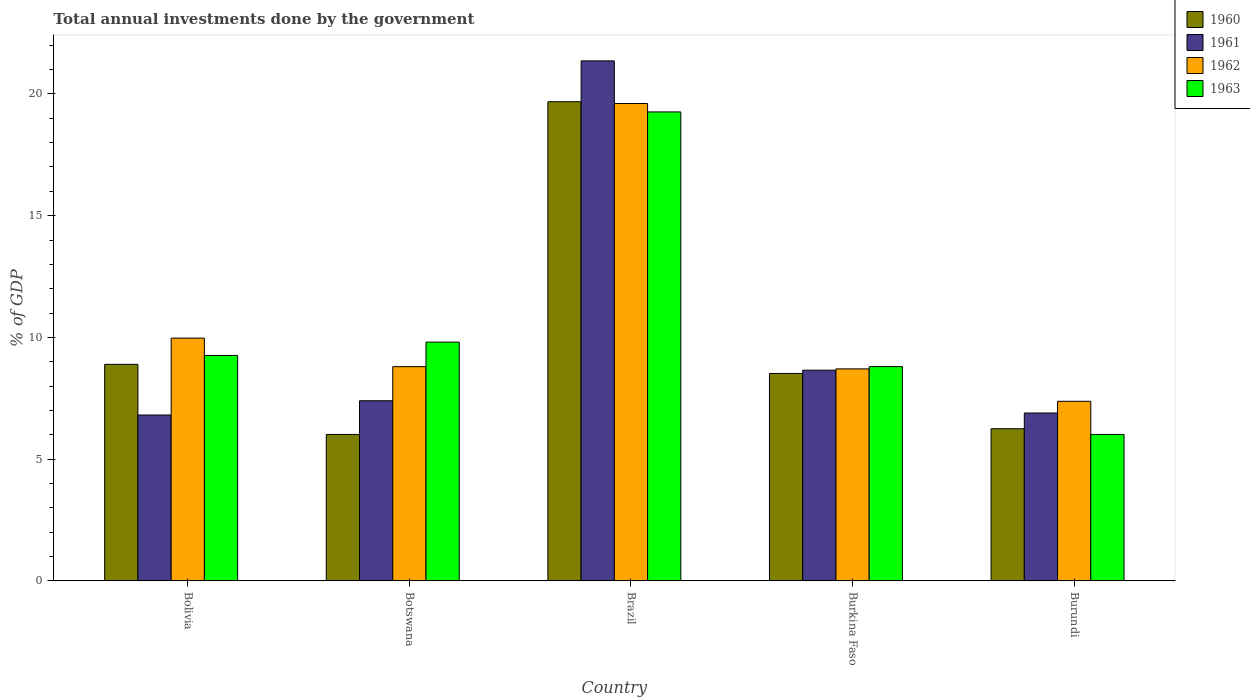How many bars are there on the 1st tick from the left?
Offer a terse response. 4. What is the label of the 4th group of bars from the left?
Ensure brevity in your answer.  Burkina Faso. In how many cases, is the number of bars for a given country not equal to the number of legend labels?
Offer a very short reply. 0. What is the total annual investments done by the government in 1960 in Burundi?
Ensure brevity in your answer.  6.25. Across all countries, what is the maximum total annual investments done by the government in 1961?
Ensure brevity in your answer.  21.36. Across all countries, what is the minimum total annual investments done by the government in 1963?
Give a very brief answer. 6.02. In which country was the total annual investments done by the government in 1963 minimum?
Keep it short and to the point. Burundi. What is the total total annual investments done by the government in 1961 in the graph?
Your answer should be very brief. 51.12. What is the difference between the total annual investments done by the government in 1962 in Brazil and that in Burundi?
Provide a succinct answer. 12.23. What is the difference between the total annual investments done by the government in 1962 in Burkina Faso and the total annual investments done by the government in 1960 in Burundi?
Provide a succinct answer. 2.46. What is the average total annual investments done by the government in 1960 per country?
Ensure brevity in your answer.  9.87. What is the difference between the total annual investments done by the government of/in 1963 and total annual investments done by the government of/in 1960 in Brazil?
Your answer should be very brief. -0.42. In how many countries, is the total annual investments done by the government in 1962 greater than 7 %?
Your response must be concise. 5. What is the ratio of the total annual investments done by the government in 1962 in Brazil to that in Burundi?
Ensure brevity in your answer.  2.66. What is the difference between the highest and the second highest total annual investments done by the government in 1963?
Keep it short and to the point. -9.45. What is the difference between the highest and the lowest total annual investments done by the government in 1961?
Your response must be concise. 14.54. In how many countries, is the total annual investments done by the government in 1963 greater than the average total annual investments done by the government in 1963 taken over all countries?
Offer a terse response. 1. Is the sum of the total annual investments done by the government in 1961 in Burkina Faso and Burundi greater than the maximum total annual investments done by the government in 1963 across all countries?
Keep it short and to the point. No. Is it the case that in every country, the sum of the total annual investments done by the government in 1961 and total annual investments done by the government in 1963 is greater than the sum of total annual investments done by the government in 1962 and total annual investments done by the government in 1960?
Your answer should be compact. No. How many bars are there?
Provide a succinct answer. 20. How many countries are there in the graph?
Provide a succinct answer. 5. Are the values on the major ticks of Y-axis written in scientific E-notation?
Offer a very short reply. No. How many legend labels are there?
Keep it short and to the point. 4. What is the title of the graph?
Your answer should be very brief. Total annual investments done by the government. What is the label or title of the X-axis?
Your answer should be compact. Country. What is the label or title of the Y-axis?
Your answer should be very brief. % of GDP. What is the % of GDP in 1960 in Bolivia?
Ensure brevity in your answer.  8.89. What is the % of GDP in 1961 in Bolivia?
Offer a terse response. 6.81. What is the % of GDP in 1962 in Bolivia?
Your answer should be compact. 9.97. What is the % of GDP of 1963 in Bolivia?
Your answer should be very brief. 9.26. What is the % of GDP in 1960 in Botswana?
Provide a succinct answer. 6.02. What is the % of GDP of 1961 in Botswana?
Offer a very short reply. 7.4. What is the % of GDP of 1962 in Botswana?
Give a very brief answer. 8.8. What is the % of GDP in 1963 in Botswana?
Ensure brevity in your answer.  9.81. What is the % of GDP of 1960 in Brazil?
Your answer should be very brief. 19.68. What is the % of GDP of 1961 in Brazil?
Make the answer very short. 21.36. What is the % of GDP of 1962 in Brazil?
Make the answer very short. 19.6. What is the % of GDP in 1963 in Brazil?
Provide a succinct answer. 19.26. What is the % of GDP of 1960 in Burkina Faso?
Offer a very short reply. 8.52. What is the % of GDP of 1961 in Burkina Faso?
Provide a succinct answer. 8.65. What is the % of GDP in 1962 in Burkina Faso?
Ensure brevity in your answer.  8.71. What is the % of GDP of 1963 in Burkina Faso?
Your answer should be compact. 8.8. What is the % of GDP of 1960 in Burundi?
Your answer should be compact. 6.25. What is the % of GDP in 1961 in Burundi?
Offer a very short reply. 6.9. What is the % of GDP of 1962 in Burundi?
Ensure brevity in your answer.  7.38. What is the % of GDP of 1963 in Burundi?
Ensure brevity in your answer.  6.02. Across all countries, what is the maximum % of GDP in 1960?
Give a very brief answer. 19.68. Across all countries, what is the maximum % of GDP of 1961?
Ensure brevity in your answer.  21.36. Across all countries, what is the maximum % of GDP of 1962?
Keep it short and to the point. 19.6. Across all countries, what is the maximum % of GDP in 1963?
Provide a short and direct response. 19.26. Across all countries, what is the minimum % of GDP of 1960?
Your response must be concise. 6.02. Across all countries, what is the minimum % of GDP in 1961?
Provide a succinct answer. 6.81. Across all countries, what is the minimum % of GDP in 1962?
Your answer should be very brief. 7.38. Across all countries, what is the minimum % of GDP of 1963?
Offer a very short reply. 6.02. What is the total % of GDP of 1960 in the graph?
Offer a terse response. 49.36. What is the total % of GDP in 1961 in the graph?
Your response must be concise. 51.12. What is the total % of GDP of 1962 in the graph?
Offer a terse response. 54.46. What is the total % of GDP in 1963 in the graph?
Your answer should be very brief. 53.14. What is the difference between the % of GDP of 1960 in Bolivia and that in Botswana?
Make the answer very short. 2.88. What is the difference between the % of GDP in 1961 in Bolivia and that in Botswana?
Provide a succinct answer. -0.59. What is the difference between the % of GDP of 1962 in Bolivia and that in Botswana?
Your answer should be very brief. 1.17. What is the difference between the % of GDP in 1963 in Bolivia and that in Botswana?
Your answer should be compact. -0.55. What is the difference between the % of GDP in 1960 in Bolivia and that in Brazil?
Provide a short and direct response. -10.78. What is the difference between the % of GDP in 1961 in Bolivia and that in Brazil?
Give a very brief answer. -14.54. What is the difference between the % of GDP of 1962 in Bolivia and that in Brazil?
Make the answer very short. -9.63. What is the difference between the % of GDP in 1963 in Bolivia and that in Brazil?
Your answer should be compact. -10. What is the difference between the % of GDP of 1960 in Bolivia and that in Burkina Faso?
Keep it short and to the point. 0.37. What is the difference between the % of GDP in 1961 in Bolivia and that in Burkina Faso?
Make the answer very short. -1.84. What is the difference between the % of GDP in 1962 in Bolivia and that in Burkina Faso?
Your answer should be very brief. 1.26. What is the difference between the % of GDP of 1963 in Bolivia and that in Burkina Faso?
Ensure brevity in your answer.  0.46. What is the difference between the % of GDP in 1960 in Bolivia and that in Burundi?
Your response must be concise. 2.64. What is the difference between the % of GDP in 1961 in Bolivia and that in Burundi?
Make the answer very short. -0.08. What is the difference between the % of GDP of 1962 in Bolivia and that in Burundi?
Provide a short and direct response. 2.59. What is the difference between the % of GDP of 1963 in Bolivia and that in Burundi?
Offer a terse response. 3.25. What is the difference between the % of GDP in 1960 in Botswana and that in Brazil?
Provide a short and direct response. -13.66. What is the difference between the % of GDP in 1961 in Botswana and that in Brazil?
Provide a short and direct response. -13.96. What is the difference between the % of GDP of 1962 in Botswana and that in Brazil?
Provide a short and direct response. -10.81. What is the difference between the % of GDP of 1963 in Botswana and that in Brazil?
Give a very brief answer. -9.45. What is the difference between the % of GDP of 1960 in Botswana and that in Burkina Faso?
Your answer should be compact. -2.5. What is the difference between the % of GDP of 1961 in Botswana and that in Burkina Faso?
Make the answer very short. -1.25. What is the difference between the % of GDP in 1962 in Botswana and that in Burkina Faso?
Ensure brevity in your answer.  0.09. What is the difference between the % of GDP of 1963 in Botswana and that in Burkina Faso?
Your answer should be compact. 1.01. What is the difference between the % of GDP of 1960 in Botswana and that in Burundi?
Make the answer very short. -0.23. What is the difference between the % of GDP in 1961 in Botswana and that in Burundi?
Provide a succinct answer. 0.5. What is the difference between the % of GDP in 1962 in Botswana and that in Burundi?
Keep it short and to the point. 1.42. What is the difference between the % of GDP of 1963 in Botswana and that in Burundi?
Give a very brief answer. 3.79. What is the difference between the % of GDP in 1960 in Brazil and that in Burkina Faso?
Your answer should be compact. 11.16. What is the difference between the % of GDP in 1961 in Brazil and that in Burkina Faso?
Ensure brevity in your answer.  12.7. What is the difference between the % of GDP in 1962 in Brazil and that in Burkina Faso?
Give a very brief answer. 10.9. What is the difference between the % of GDP of 1963 in Brazil and that in Burkina Faso?
Provide a short and direct response. 10.46. What is the difference between the % of GDP in 1960 in Brazil and that in Burundi?
Ensure brevity in your answer.  13.43. What is the difference between the % of GDP in 1961 in Brazil and that in Burundi?
Provide a succinct answer. 14.46. What is the difference between the % of GDP of 1962 in Brazil and that in Burundi?
Make the answer very short. 12.23. What is the difference between the % of GDP in 1963 in Brazil and that in Burundi?
Your response must be concise. 13.24. What is the difference between the % of GDP in 1960 in Burkina Faso and that in Burundi?
Provide a succinct answer. 2.27. What is the difference between the % of GDP of 1961 in Burkina Faso and that in Burundi?
Offer a very short reply. 1.76. What is the difference between the % of GDP in 1962 in Burkina Faso and that in Burundi?
Provide a short and direct response. 1.33. What is the difference between the % of GDP of 1963 in Burkina Faso and that in Burundi?
Offer a terse response. 2.79. What is the difference between the % of GDP in 1960 in Bolivia and the % of GDP in 1961 in Botswana?
Give a very brief answer. 1.49. What is the difference between the % of GDP of 1960 in Bolivia and the % of GDP of 1962 in Botswana?
Make the answer very short. 0.1. What is the difference between the % of GDP of 1960 in Bolivia and the % of GDP of 1963 in Botswana?
Keep it short and to the point. -0.91. What is the difference between the % of GDP of 1961 in Bolivia and the % of GDP of 1962 in Botswana?
Ensure brevity in your answer.  -1.99. What is the difference between the % of GDP in 1961 in Bolivia and the % of GDP in 1963 in Botswana?
Provide a succinct answer. -2.99. What is the difference between the % of GDP in 1962 in Bolivia and the % of GDP in 1963 in Botswana?
Your response must be concise. 0.16. What is the difference between the % of GDP in 1960 in Bolivia and the % of GDP in 1961 in Brazil?
Your answer should be compact. -12.46. What is the difference between the % of GDP of 1960 in Bolivia and the % of GDP of 1962 in Brazil?
Offer a very short reply. -10.71. What is the difference between the % of GDP of 1960 in Bolivia and the % of GDP of 1963 in Brazil?
Your answer should be very brief. -10.37. What is the difference between the % of GDP in 1961 in Bolivia and the % of GDP in 1962 in Brazil?
Your response must be concise. -12.79. What is the difference between the % of GDP of 1961 in Bolivia and the % of GDP of 1963 in Brazil?
Make the answer very short. -12.45. What is the difference between the % of GDP in 1962 in Bolivia and the % of GDP in 1963 in Brazil?
Offer a very short reply. -9.29. What is the difference between the % of GDP in 1960 in Bolivia and the % of GDP in 1961 in Burkina Faso?
Ensure brevity in your answer.  0.24. What is the difference between the % of GDP in 1960 in Bolivia and the % of GDP in 1962 in Burkina Faso?
Offer a very short reply. 0.19. What is the difference between the % of GDP of 1960 in Bolivia and the % of GDP of 1963 in Burkina Faso?
Keep it short and to the point. 0.09. What is the difference between the % of GDP in 1961 in Bolivia and the % of GDP in 1962 in Burkina Faso?
Offer a terse response. -1.89. What is the difference between the % of GDP of 1961 in Bolivia and the % of GDP of 1963 in Burkina Faso?
Offer a terse response. -1.99. What is the difference between the % of GDP in 1962 in Bolivia and the % of GDP in 1963 in Burkina Faso?
Your response must be concise. 1.17. What is the difference between the % of GDP of 1960 in Bolivia and the % of GDP of 1961 in Burundi?
Give a very brief answer. 2. What is the difference between the % of GDP in 1960 in Bolivia and the % of GDP in 1962 in Burundi?
Your answer should be compact. 1.52. What is the difference between the % of GDP in 1960 in Bolivia and the % of GDP in 1963 in Burundi?
Make the answer very short. 2.88. What is the difference between the % of GDP of 1961 in Bolivia and the % of GDP of 1962 in Burundi?
Give a very brief answer. -0.56. What is the difference between the % of GDP in 1961 in Bolivia and the % of GDP in 1963 in Burundi?
Offer a very short reply. 0.8. What is the difference between the % of GDP in 1962 in Bolivia and the % of GDP in 1963 in Burundi?
Provide a short and direct response. 3.96. What is the difference between the % of GDP of 1960 in Botswana and the % of GDP of 1961 in Brazil?
Offer a very short reply. -15.34. What is the difference between the % of GDP of 1960 in Botswana and the % of GDP of 1962 in Brazil?
Offer a very short reply. -13.59. What is the difference between the % of GDP of 1960 in Botswana and the % of GDP of 1963 in Brazil?
Make the answer very short. -13.24. What is the difference between the % of GDP of 1961 in Botswana and the % of GDP of 1962 in Brazil?
Give a very brief answer. -12.21. What is the difference between the % of GDP of 1961 in Botswana and the % of GDP of 1963 in Brazil?
Make the answer very short. -11.86. What is the difference between the % of GDP in 1962 in Botswana and the % of GDP in 1963 in Brazil?
Offer a very short reply. -10.46. What is the difference between the % of GDP in 1960 in Botswana and the % of GDP in 1961 in Burkina Faso?
Give a very brief answer. -2.64. What is the difference between the % of GDP of 1960 in Botswana and the % of GDP of 1962 in Burkina Faso?
Offer a terse response. -2.69. What is the difference between the % of GDP of 1960 in Botswana and the % of GDP of 1963 in Burkina Faso?
Keep it short and to the point. -2.79. What is the difference between the % of GDP in 1961 in Botswana and the % of GDP in 1962 in Burkina Faso?
Your answer should be very brief. -1.31. What is the difference between the % of GDP in 1961 in Botswana and the % of GDP in 1963 in Burkina Faso?
Your answer should be compact. -1.4. What is the difference between the % of GDP in 1962 in Botswana and the % of GDP in 1963 in Burkina Faso?
Provide a succinct answer. -0. What is the difference between the % of GDP of 1960 in Botswana and the % of GDP of 1961 in Burundi?
Ensure brevity in your answer.  -0.88. What is the difference between the % of GDP in 1960 in Botswana and the % of GDP in 1962 in Burundi?
Your answer should be compact. -1.36. What is the difference between the % of GDP in 1960 in Botswana and the % of GDP in 1963 in Burundi?
Provide a short and direct response. 0. What is the difference between the % of GDP of 1961 in Botswana and the % of GDP of 1962 in Burundi?
Keep it short and to the point. 0.02. What is the difference between the % of GDP of 1961 in Botswana and the % of GDP of 1963 in Burundi?
Provide a succinct answer. 1.38. What is the difference between the % of GDP of 1962 in Botswana and the % of GDP of 1963 in Burundi?
Provide a succinct answer. 2.78. What is the difference between the % of GDP of 1960 in Brazil and the % of GDP of 1961 in Burkina Faso?
Your answer should be compact. 11.02. What is the difference between the % of GDP in 1960 in Brazil and the % of GDP in 1962 in Burkina Faso?
Provide a succinct answer. 10.97. What is the difference between the % of GDP of 1960 in Brazil and the % of GDP of 1963 in Burkina Faso?
Keep it short and to the point. 10.88. What is the difference between the % of GDP in 1961 in Brazil and the % of GDP in 1962 in Burkina Faso?
Make the answer very short. 12.65. What is the difference between the % of GDP in 1961 in Brazil and the % of GDP in 1963 in Burkina Faso?
Offer a terse response. 12.55. What is the difference between the % of GDP in 1962 in Brazil and the % of GDP in 1963 in Burkina Faso?
Make the answer very short. 10.8. What is the difference between the % of GDP in 1960 in Brazil and the % of GDP in 1961 in Burundi?
Make the answer very short. 12.78. What is the difference between the % of GDP in 1960 in Brazil and the % of GDP in 1962 in Burundi?
Provide a succinct answer. 12.3. What is the difference between the % of GDP of 1960 in Brazil and the % of GDP of 1963 in Burundi?
Ensure brevity in your answer.  13.66. What is the difference between the % of GDP in 1961 in Brazil and the % of GDP in 1962 in Burundi?
Offer a terse response. 13.98. What is the difference between the % of GDP of 1961 in Brazil and the % of GDP of 1963 in Burundi?
Your answer should be compact. 15.34. What is the difference between the % of GDP in 1962 in Brazil and the % of GDP in 1963 in Burundi?
Keep it short and to the point. 13.59. What is the difference between the % of GDP in 1960 in Burkina Faso and the % of GDP in 1961 in Burundi?
Make the answer very short. 1.62. What is the difference between the % of GDP of 1960 in Burkina Faso and the % of GDP of 1962 in Burundi?
Provide a succinct answer. 1.14. What is the difference between the % of GDP in 1960 in Burkina Faso and the % of GDP in 1963 in Burundi?
Your answer should be very brief. 2.5. What is the difference between the % of GDP in 1961 in Burkina Faso and the % of GDP in 1962 in Burundi?
Provide a succinct answer. 1.28. What is the difference between the % of GDP of 1961 in Burkina Faso and the % of GDP of 1963 in Burundi?
Your response must be concise. 2.64. What is the difference between the % of GDP in 1962 in Burkina Faso and the % of GDP in 1963 in Burundi?
Provide a short and direct response. 2.69. What is the average % of GDP of 1960 per country?
Provide a succinct answer. 9.87. What is the average % of GDP in 1961 per country?
Provide a short and direct response. 10.22. What is the average % of GDP in 1962 per country?
Offer a terse response. 10.89. What is the average % of GDP of 1963 per country?
Your response must be concise. 10.63. What is the difference between the % of GDP of 1960 and % of GDP of 1961 in Bolivia?
Your answer should be compact. 2.08. What is the difference between the % of GDP in 1960 and % of GDP in 1962 in Bolivia?
Your answer should be compact. -1.08. What is the difference between the % of GDP in 1960 and % of GDP in 1963 in Bolivia?
Provide a succinct answer. -0.37. What is the difference between the % of GDP in 1961 and % of GDP in 1962 in Bolivia?
Offer a terse response. -3.16. What is the difference between the % of GDP of 1961 and % of GDP of 1963 in Bolivia?
Your answer should be very brief. -2.45. What is the difference between the % of GDP in 1962 and % of GDP in 1963 in Bolivia?
Offer a terse response. 0.71. What is the difference between the % of GDP in 1960 and % of GDP in 1961 in Botswana?
Offer a terse response. -1.38. What is the difference between the % of GDP in 1960 and % of GDP in 1962 in Botswana?
Give a very brief answer. -2.78. What is the difference between the % of GDP in 1960 and % of GDP in 1963 in Botswana?
Your response must be concise. -3.79. What is the difference between the % of GDP in 1961 and % of GDP in 1962 in Botswana?
Keep it short and to the point. -1.4. What is the difference between the % of GDP in 1961 and % of GDP in 1963 in Botswana?
Offer a very short reply. -2.41. What is the difference between the % of GDP of 1962 and % of GDP of 1963 in Botswana?
Keep it short and to the point. -1.01. What is the difference between the % of GDP of 1960 and % of GDP of 1961 in Brazil?
Your answer should be compact. -1.68. What is the difference between the % of GDP in 1960 and % of GDP in 1962 in Brazil?
Your answer should be compact. 0.07. What is the difference between the % of GDP in 1960 and % of GDP in 1963 in Brazil?
Provide a short and direct response. 0.42. What is the difference between the % of GDP of 1961 and % of GDP of 1962 in Brazil?
Provide a succinct answer. 1.75. What is the difference between the % of GDP in 1961 and % of GDP in 1963 in Brazil?
Your answer should be very brief. 2.1. What is the difference between the % of GDP in 1962 and % of GDP in 1963 in Brazil?
Your answer should be compact. 0.34. What is the difference between the % of GDP of 1960 and % of GDP of 1961 in Burkina Faso?
Make the answer very short. -0.13. What is the difference between the % of GDP of 1960 and % of GDP of 1962 in Burkina Faso?
Give a very brief answer. -0.19. What is the difference between the % of GDP in 1960 and % of GDP in 1963 in Burkina Faso?
Keep it short and to the point. -0.28. What is the difference between the % of GDP of 1961 and % of GDP of 1962 in Burkina Faso?
Keep it short and to the point. -0.05. What is the difference between the % of GDP of 1961 and % of GDP of 1963 in Burkina Faso?
Offer a very short reply. -0.15. What is the difference between the % of GDP in 1962 and % of GDP in 1963 in Burkina Faso?
Make the answer very short. -0.09. What is the difference between the % of GDP in 1960 and % of GDP in 1961 in Burundi?
Offer a terse response. -0.65. What is the difference between the % of GDP in 1960 and % of GDP in 1962 in Burundi?
Your answer should be very brief. -1.13. What is the difference between the % of GDP of 1960 and % of GDP of 1963 in Burundi?
Give a very brief answer. 0.23. What is the difference between the % of GDP in 1961 and % of GDP in 1962 in Burundi?
Offer a terse response. -0.48. What is the difference between the % of GDP in 1961 and % of GDP in 1963 in Burundi?
Your answer should be compact. 0.88. What is the difference between the % of GDP in 1962 and % of GDP in 1963 in Burundi?
Keep it short and to the point. 1.36. What is the ratio of the % of GDP in 1960 in Bolivia to that in Botswana?
Make the answer very short. 1.48. What is the ratio of the % of GDP in 1961 in Bolivia to that in Botswana?
Your answer should be compact. 0.92. What is the ratio of the % of GDP in 1962 in Bolivia to that in Botswana?
Give a very brief answer. 1.13. What is the ratio of the % of GDP in 1963 in Bolivia to that in Botswana?
Offer a very short reply. 0.94. What is the ratio of the % of GDP in 1960 in Bolivia to that in Brazil?
Provide a short and direct response. 0.45. What is the ratio of the % of GDP of 1961 in Bolivia to that in Brazil?
Keep it short and to the point. 0.32. What is the ratio of the % of GDP in 1962 in Bolivia to that in Brazil?
Ensure brevity in your answer.  0.51. What is the ratio of the % of GDP in 1963 in Bolivia to that in Brazil?
Offer a terse response. 0.48. What is the ratio of the % of GDP in 1960 in Bolivia to that in Burkina Faso?
Offer a terse response. 1.04. What is the ratio of the % of GDP of 1961 in Bolivia to that in Burkina Faso?
Give a very brief answer. 0.79. What is the ratio of the % of GDP of 1962 in Bolivia to that in Burkina Faso?
Offer a terse response. 1.15. What is the ratio of the % of GDP in 1963 in Bolivia to that in Burkina Faso?
Your answer should be compact. 1.05. What is the ratio of the % of GDP of 1960 in Bolivia to that in Burundi?
Offer a terse response. 1.42. What is the ratio of the % of GDP of 1961 in Bolivia to that in Burundi?
Give a very brief answer. 0.99. What is the ratio of the % of GDP in 1962 in Bolivia to that in Burundi?
Keep it short and to the point. 1.35. What is the ratio of the % of GDP in 1963 in Bolivia to that in Burundi?
Keep it short and to the point. 1.54. What is the ratio of the % of GDP of 1960 in Botswana to that in Brazil?
Make the answer very short. 0.31. What is the ratio of the % of GDP of 1961 in Botswana to that in Brazil?
Offer a very short reply. 0.35. What is the ratio of the % of GDP in 1962 in Botswana to that in Brazil?
Offer a terse response. 0.45. What is the ratio of the % of GDP in 1963 in Botswana to that in Brazil?
Your response must be concise. 0.51. What is the ratio of the % of GDP in 1960 in Botswana to that in Burkina Faso?
Provide a succinct answer. 0.71. What is the ratio of the % of GDP of 1961 in Botswana to that in Burkina Faso?
Provide a short and direct response. 0.85. What is the ratio of the % of GDP in 1962 in Botswana to that in Burkina Faso?
Provide a succinct answer. 1.01. What is the ratio of the % of GDP in 1963 in Botswana to that in Burkina Faso?
Ensure brevity in your answer.  1.11. What is the ratio of the % of GDP of 1960 in Botswana to that in Burundi?
Offer a very short reply. 0.96. What is the ratio of the % of GDP in 1961 in Botswana to that in Burundi?
Your answer should be compact. 1.07. What is the ratio of the % of GDP in 1962 in Botswana to that in Burundi?
Keep it short and to the point. 1.19. What is the ratio of the % of GDP in 1963 in Botswana to that in Burundi?
Ensure brevity in your answer.  1.63. What is the ratio of the % of GDP in 1960 in Brazil to that in Burkina Faso?
Provide a succinct answer. 2.31. What is the ratio of the % of GDP in 1961 in Brazil to that in Burkina Faso?
Offer a terse response. 2.47. What is the ratio of the % of GDP in 1962 in Brazil to that in Burkina Faso?
Ensure brevity in your answer.  2.25. What is the ratio of the % of GDP of 1963 in Brazil to that in Burkina Faso?
Your answer should be very brief. 2.19. What is the ratio of the % of GDP of 1960 in Brazil to that in Burundi?
Keep it short and to the point. 3.15. What is the ratio of the % of GDP in 1961 in Brazil to that in Burundi?
Your answer should be compact. 3.1. What is the ratio of the % of GDP in 1962 in Brazil to that in Burundi?
Give a very brief answer. 2.66. What is the ratio of the % of GDP in 1963 in Brazil to that in Burundi?
Your response must be concise. 3.2. What is the ratio of the % of GDP of 1960 in Burkina Faso to that in Burundi?
Provide a succinct answer. 1.36. What is the ratio of the % of GDP of 1961 in Burkina Faso to that in Burundi?
Keep it short and to the point. 1.25. What is the ratio of the % of GDP in 1962 in Burkina Faso to that in Burundi?
Your response must be concise. 1.18. What is the ratio of the % of GDP of 1963 in Burkina Faso to that in Burundi?
Make the answer very short. 1.46. What is the difference between the highest and the second highest % of GDP in 1960?
Keep it short and to the point. 10.78. What is the difference between the highest and the second highest % of GDP in 1961?
Your answer should be very brief. 12.7. What is the difference between the highest and the second highest % of GDP in 1962?
Offer a very short reply. 9.63. What is the difference between the highest and the second highest % of GDP in 1963?
Your response must be concise. 9.45. What is the difference between the highest and the lowest % of GDP in 1960?
Keep it short and to the point. 13.66. What is the difference between the highest and the lowest % of GDP of 1961?
Keep it short and to the point. 14.54. What is the difference between the highest and the lowest % of GDP in 1962?
Provide a succinct answer. 12.23. What is the difference between the highest and the lowest % of GDP in 1963?
Your answer should be very brief. 13.24. 